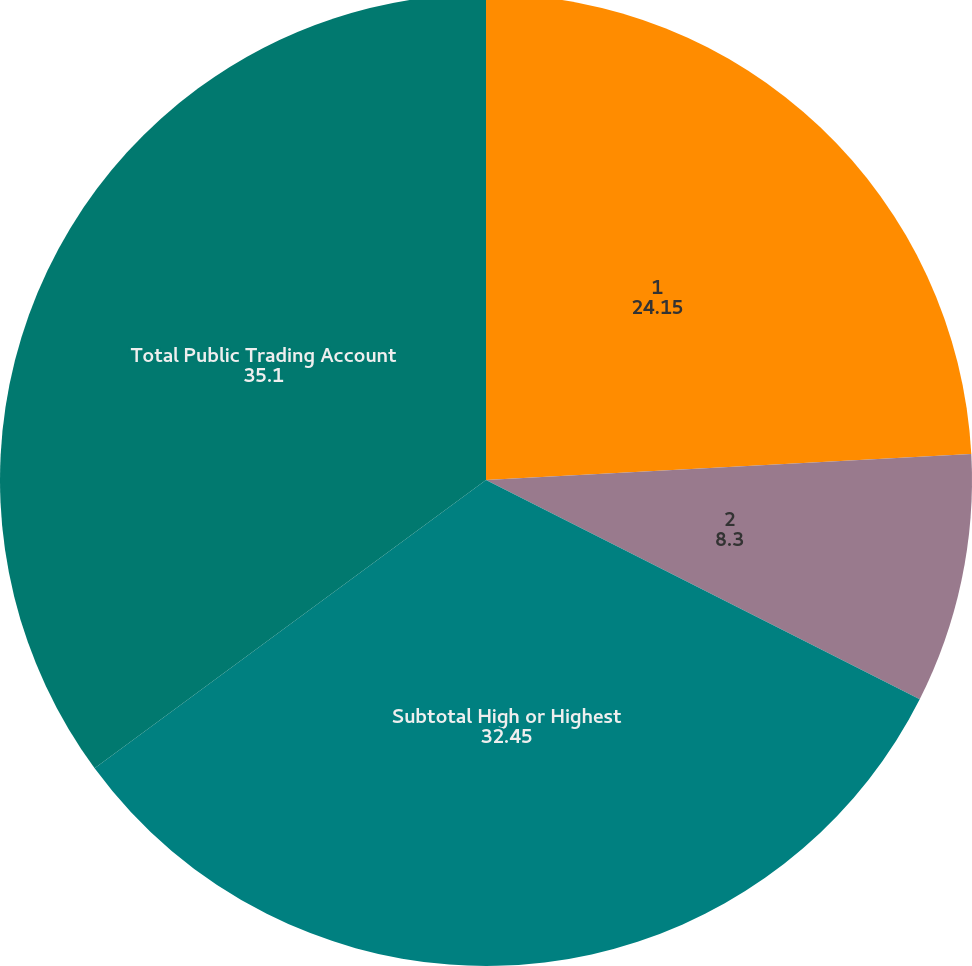<chart> <loc_0><loc_0><loc_500><loc_500><pie_chart><fcel>1<fcel>2<fcel>Subtotal High or Highest<fcel>Total Public Trading Account<nl><fcel>24.15%<fcel>8.3%<fcel>32.45%<fcel>35.1%<nl></chart> 